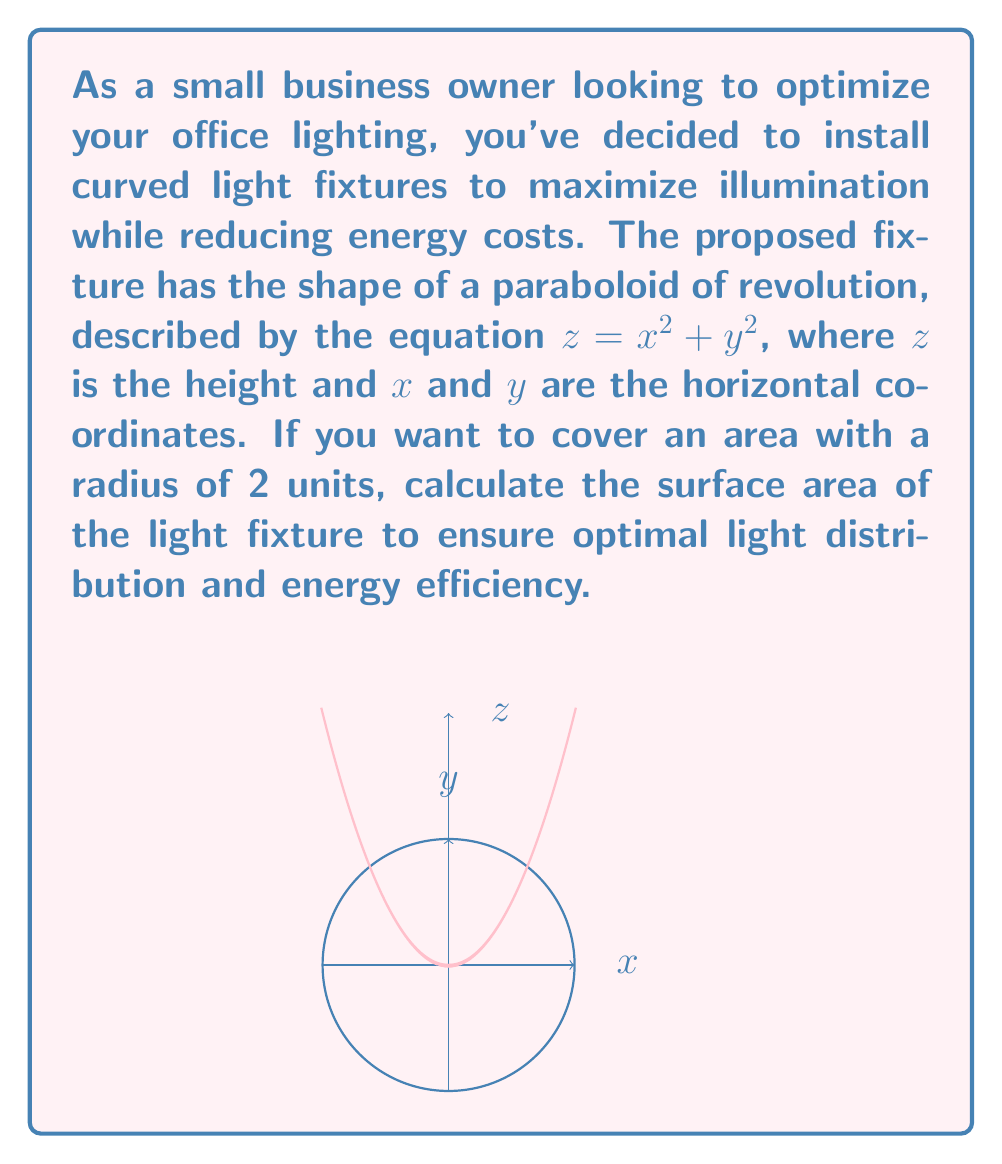Teach me how to tackle this problem. To calculate the surface area of the paraboloid light fixture, we'll follow these steps:

1) The surface area of a paraboloid of revolution can be calculated using the formula:

   $$A = \frac{\pi}{2a}[(r^2 + 4a^2)^{3/2} - (4a^2)^{3/2}]$$

   where $a$ is the coefficient of $x^2$ and $y^2$ in the equation of the paraboloid, and $r$ is the radius of the base.

2) In our case, $z = x^2 + y^2$, so $a = 1$, and we're given that $r = 2$.

3) Substituting these values into the formula:

   $$A = \frac{\pi}{2(1)}[(2^2 + 4(1)^2)^{3/2} - (4(1)^2)^{3/2}]$$

4) Simplify:
   $$A = \frac{\pi}{2}[(4 + 4)^{3/2} - 4^{3/2}]$$
   $$A = \frac{\pi}{2}[8^{3/2} - 4^{3/2}]$$

5) Calculate:
   $$A = \frac{\pi}{2}[22.627417 - 8]$$
   $$A = \frac{\pi}{2}[14.627417]$$
   $$A = 7.313708\pi$$

6) Round to two decimal places:
   $$A \approx 22.98 \text{ square units}$$

This surface area ensures optimal light distribution for the given dimensions, helping to maximize illumination while minimizing energy usage.
Answer: $22.98 \text{ square units}$ 